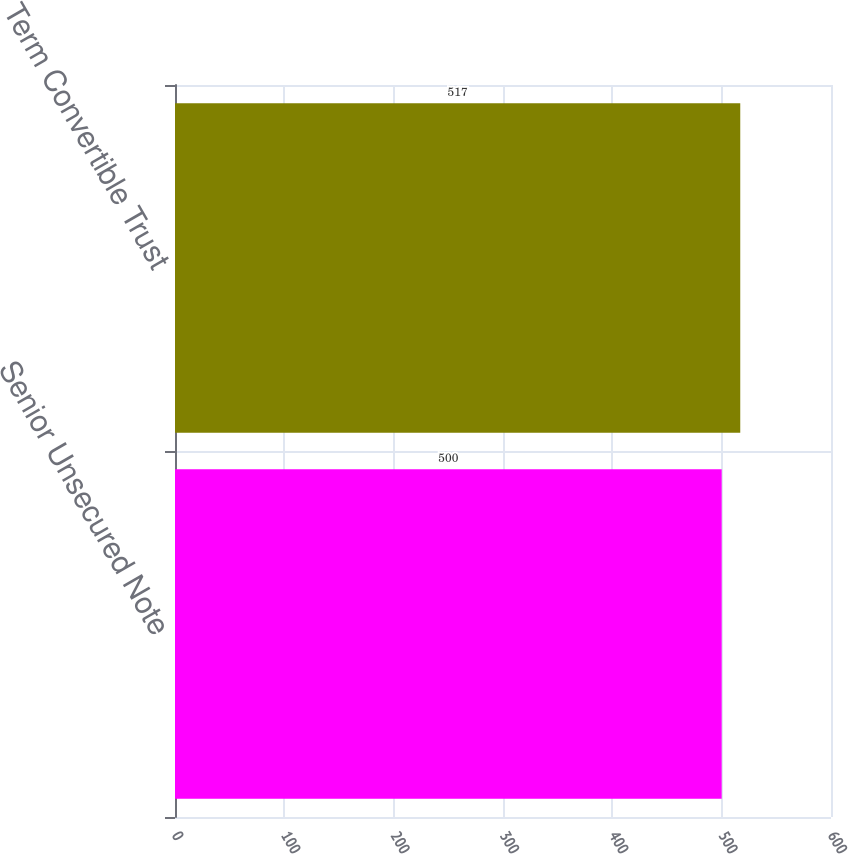<chart> <loc_0><loc_0><loc_500><loc_500><bar_chart><fcel>Senior Unsecured Note<fcel>Term Convertible Trust<nl><fcel>500<fcel>517<nl></chart> 